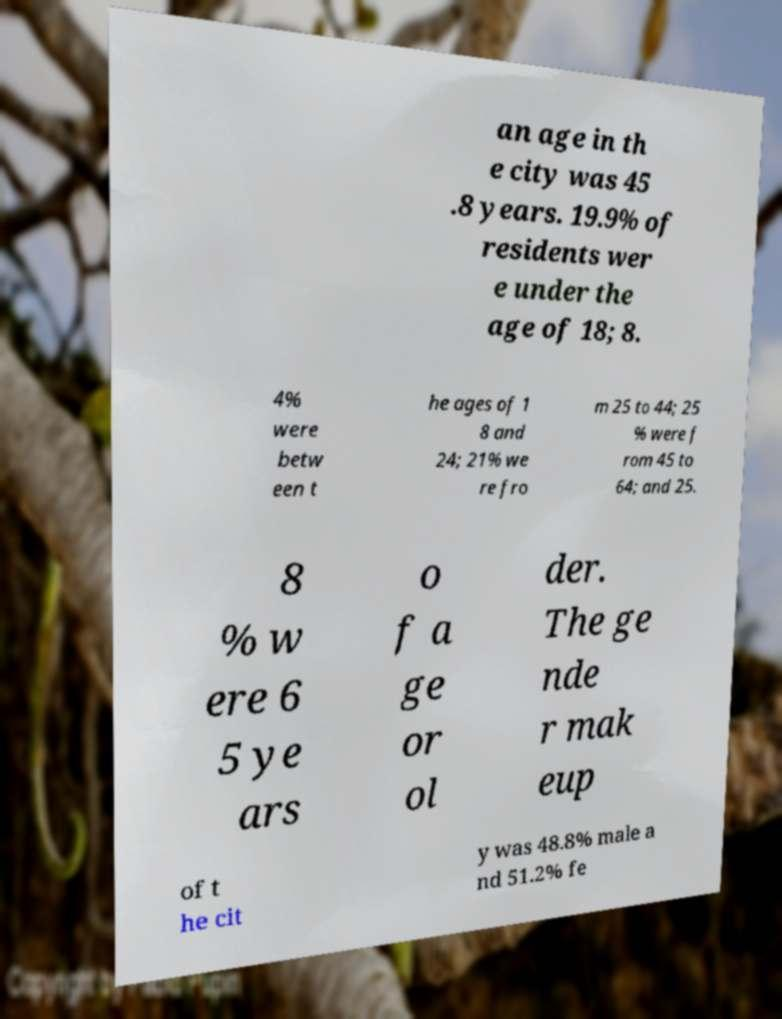Please read and relay the text visible in this image. What does it say? an age in th e city was 45 .8 years. 19.9% of residents wer e under the age of 18; 8. 4% were betw een t he ages of 1 8 and 24; 21% we re fro m 25 to 44; 25 % were f rom 45 to 64; and 25. 8 % w ere 6 5 ye ars o f a ge or ol der. The ge nde r mak eup of t he cit y was 48.8% male a nd 51.2% fe 